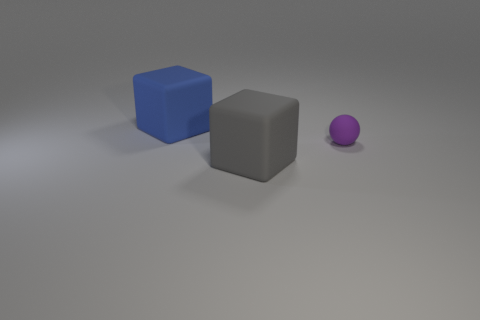The other small thing that is made of the same material as the gray thing is what shape?
Your answer should be compact. Sphere. Is there anything else that is the same size as the matte ball?
Keep it short and to the point. No. What number of big gray matte objects are the same shape as the blue matte thing?
Your response must be concise. 1. There is a purple thing that is the same material as the large blue block; what size is it?
Provide a succinct answer. Small. Is the gray rubber thing the same size as the purple matte sphere?
Your answer should be compact. No. Are any big matte cylinders visible?
Your response must be concise. No. There is a matte block behind the large rubber thing in front of the object behind the small purple ball; what size is it?
Offer a terse response. Large. What number of other blue objects are the same material as the blue thing?
Offer a terse response. 0. What number of matte balls are the same size as the blue block?
Offer a terse response. 0. What is the material of the large block that is behind the cube on the right side of the rubber object left of the gray thing?
Offer a terse response. Rubber. 